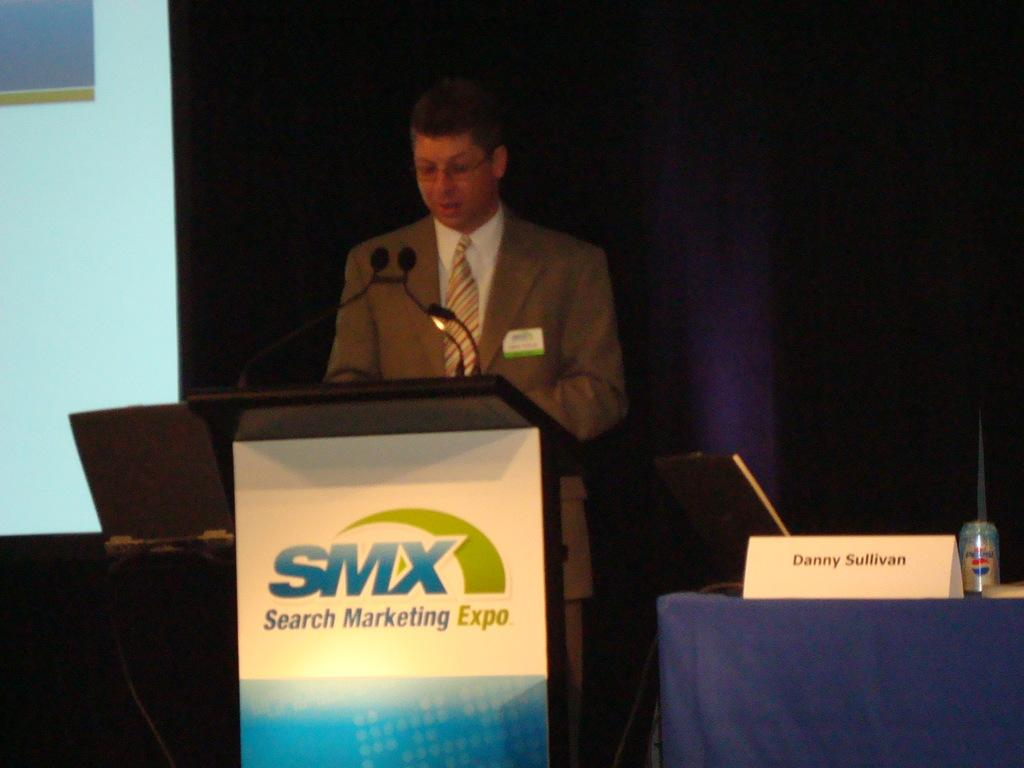Provide a one-sentence caption for the provided image. Danny Sullivan speaks at the Search Marketing Expo. 